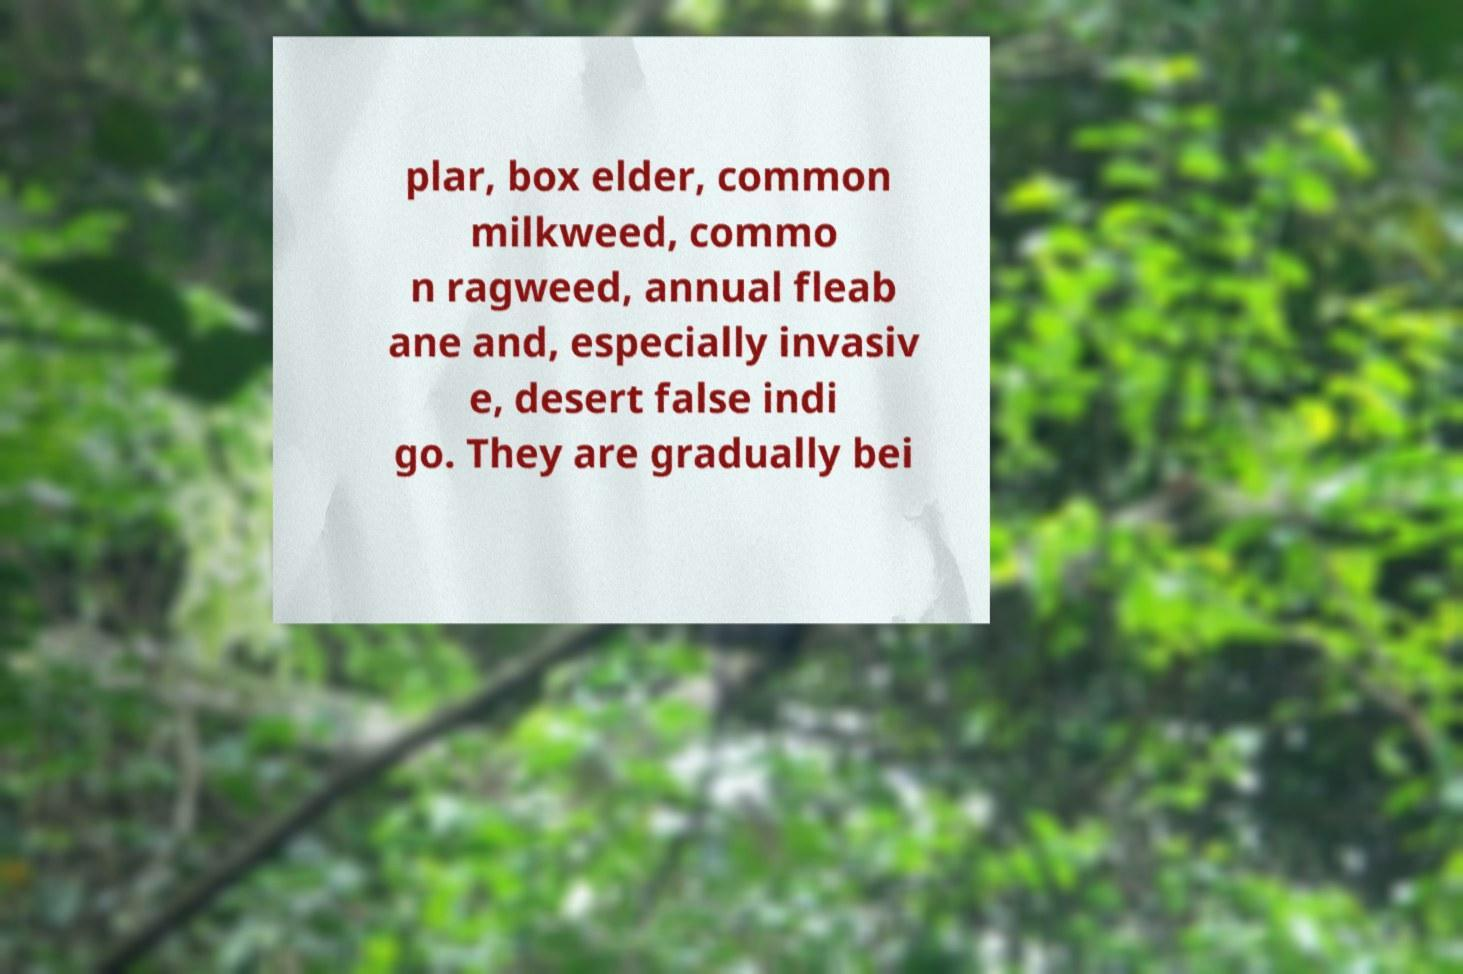What messages or text are displayed in this image? I need them in a readable, typed format. plar, box elder, common milkweed, commo n ragweed, annual fleab ane and, especially invasiv e, desert false indi go. They are gradually bei 